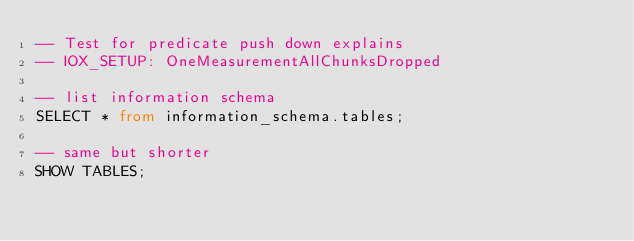<code> <loc_0><loc_0><loc_500><loc_500><_SQL_>-- Test for predicate push down explains
-- IOX_SETUP: OneMeasurementAllChunksDropped

-- list information schema
SELECT * from information_schema.tables;

-- same but shorter
SHOW TABLES;
</code> 